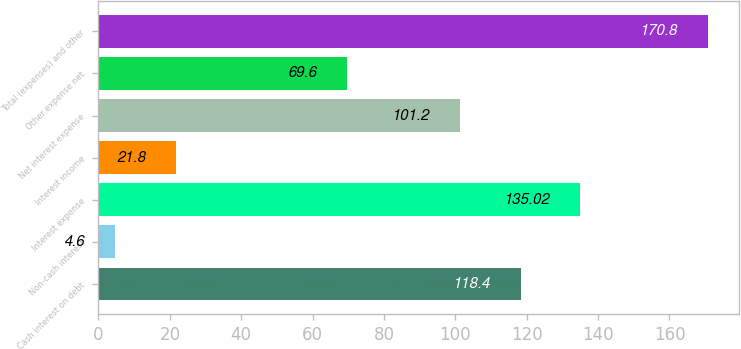<chart> <loc_0><loc_0><loc_500><loc_500><bar_chart><fcel>Cash interest on debt<fcel>Non-cash interest<fcel>Interest expense<fcel>Interest income<fcel>Net interest expense<fcel>Other expense net<fcel>Total (expenses) and other<nl><fcel>118.4<fcel>4.6<fcel>135.02<fcel>21.8<fcel>101.2<fcel>69.6<fcel>170.8<nl></chart> 